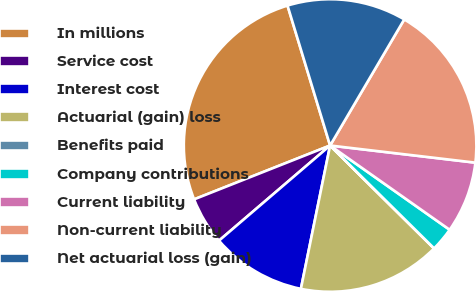Convert chart to OTSL. <chart><loc_0><loc_0><loc_500><loc_500><pie_chart><fcel>In millions<fcel>Service cost<fcel>Interest cost<fcel>Actuarial (gain) loss<fcel>Benefits paid<fcel>Company contributions<fcel>Current liability<fcel>Non-current liability<fcel>Net actuarial loss (gain)<nl><fcel>26.3%<fcel>5.27%<fcel>10.53%<fcel>15.78%<fcel>0.01%<fcel>2.64%<fcel>7.9%<fcel>18.41%<fcel>13.16%<nl></chart> 